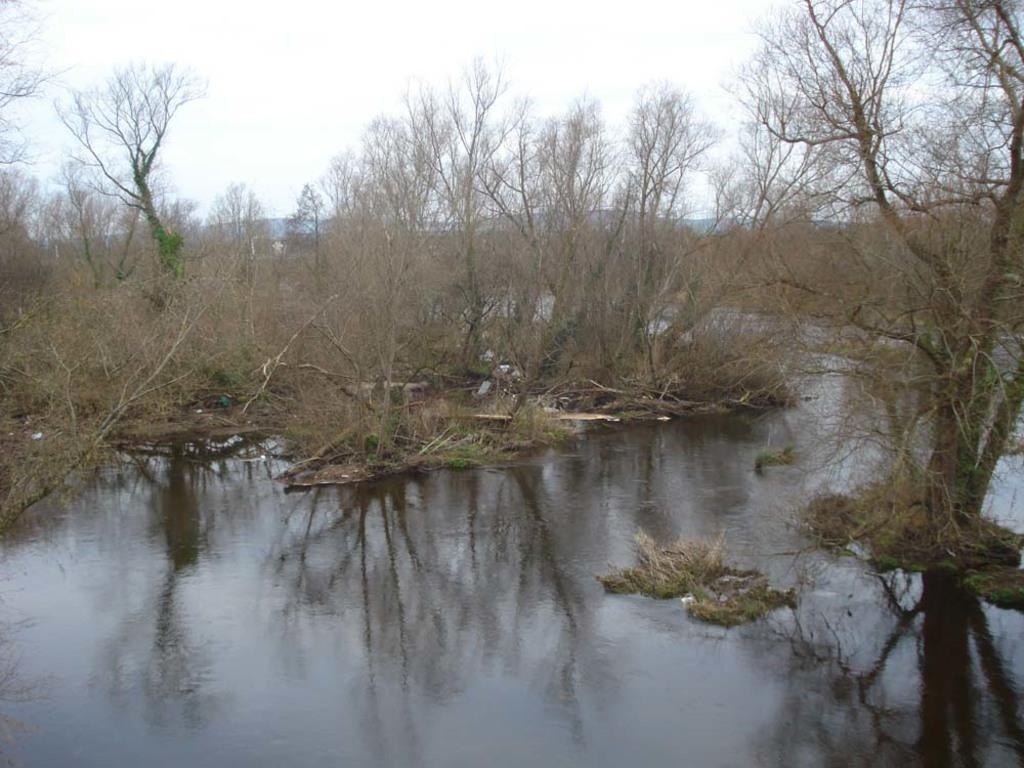What is the primary element visible in the image? There is water in the image. What can be seen in the background of the image? There are trees and mountains in the background of the image. What else is visible in the background of the image? The sky is visible in the background of the image. How many bells can be heard ringing in the image? There are no bells present in the image, so it is not possible to determine how many might be ringing. 